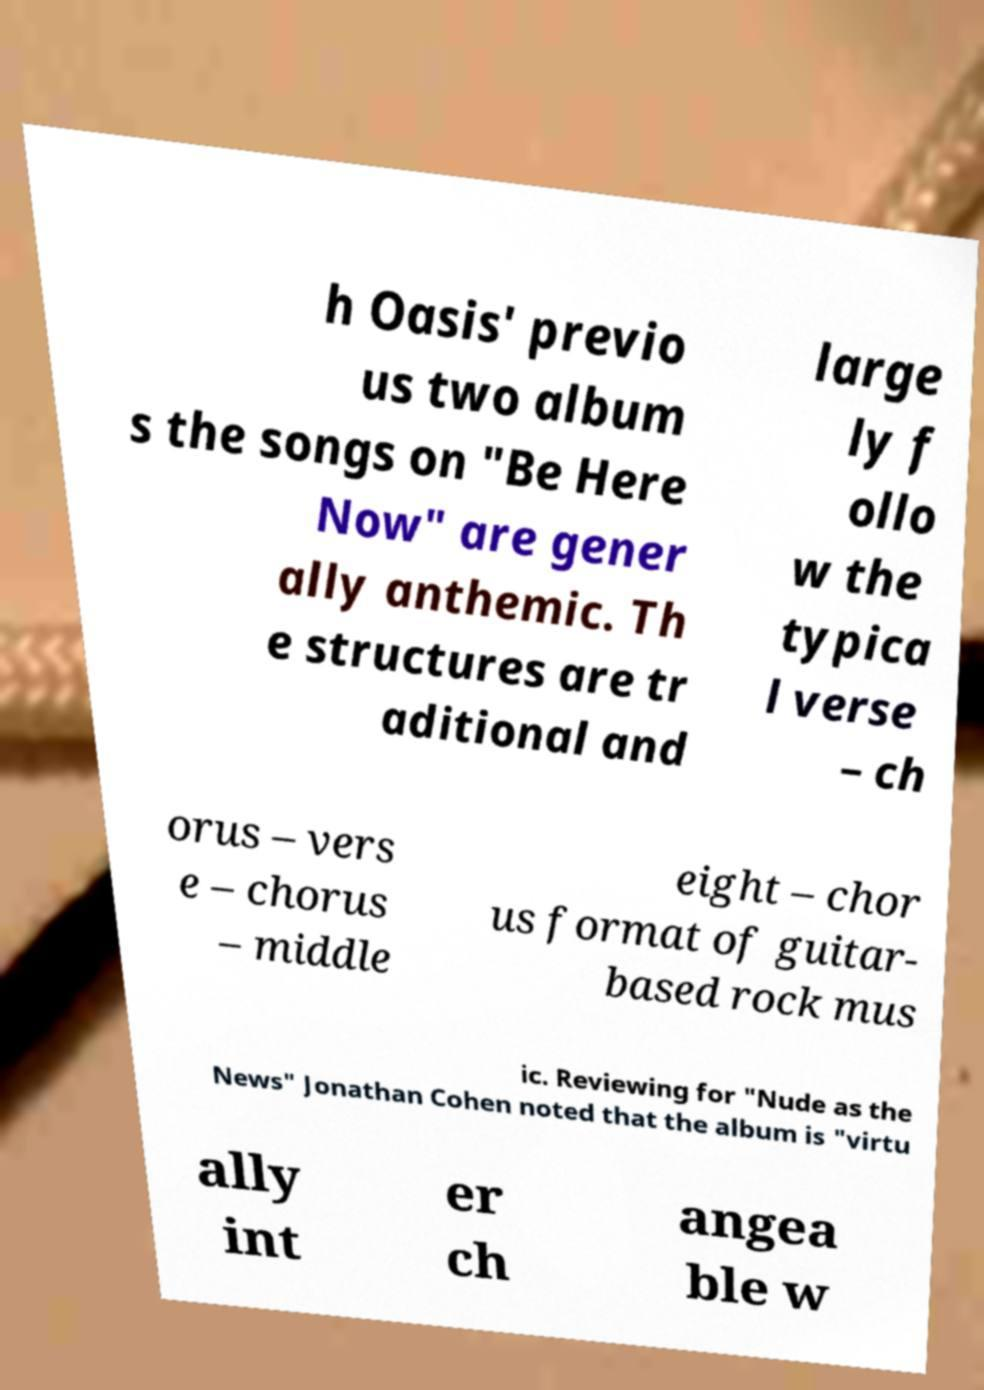Could you assist in decoding the text presented in this image and type it out clearly? h Oasis' previo us two album s the songs on "Be Here Now" are gener ally anthemic. Th e structures are tr aditional and large ly f ollo w the typica l verse – ch orus – vers e – chorus – middle eight – chor us format of guitar- based rock mus ic. Reviewing for "Nude as the News" Jonathan Cohen noted that the album is "virtu ally int er ch angea ble w 